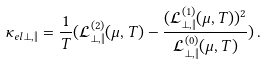<formula> <loc_0><loc_0><loc_500><loc_500>\kappa _ { e l } { _ { \perp , \| } } = \frac { 1 } { T } ( \mathcal { L } _ { \perp , \| } ^ { ( 2 ) } ( \mu , T ) - \frac { ( \mathcal { L } _ { \perp , \| } ^ { ( 1 ) } ( \mu , T ) ) ^ { 2 } } { \mathcal { L } _ { \perp , \| } ^ { ( 0 ) } ( \mu , T ) } ) \, .</formula> 